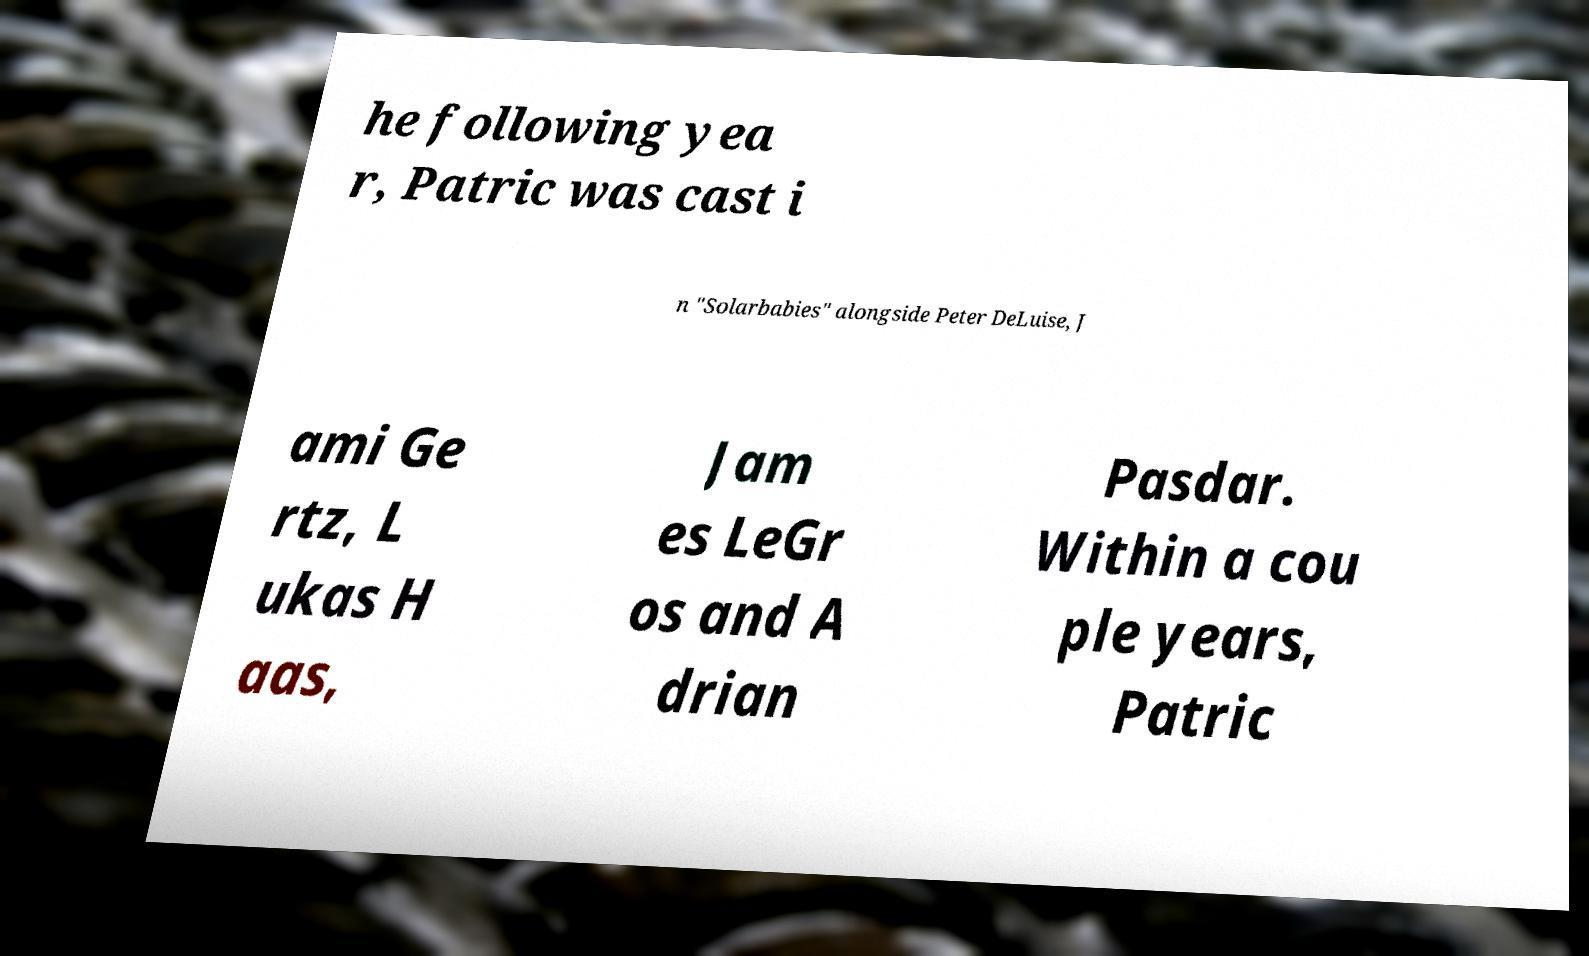Please identify and transcribe the text found in this image. he following yea r, Patric was cast i n "Solarbabies" alongside Peter DeLuise, J ami Ge rtz, L ukas H aas, Jam es LeGr os and A drian Pasdar. Within a cou ple years, Patric 